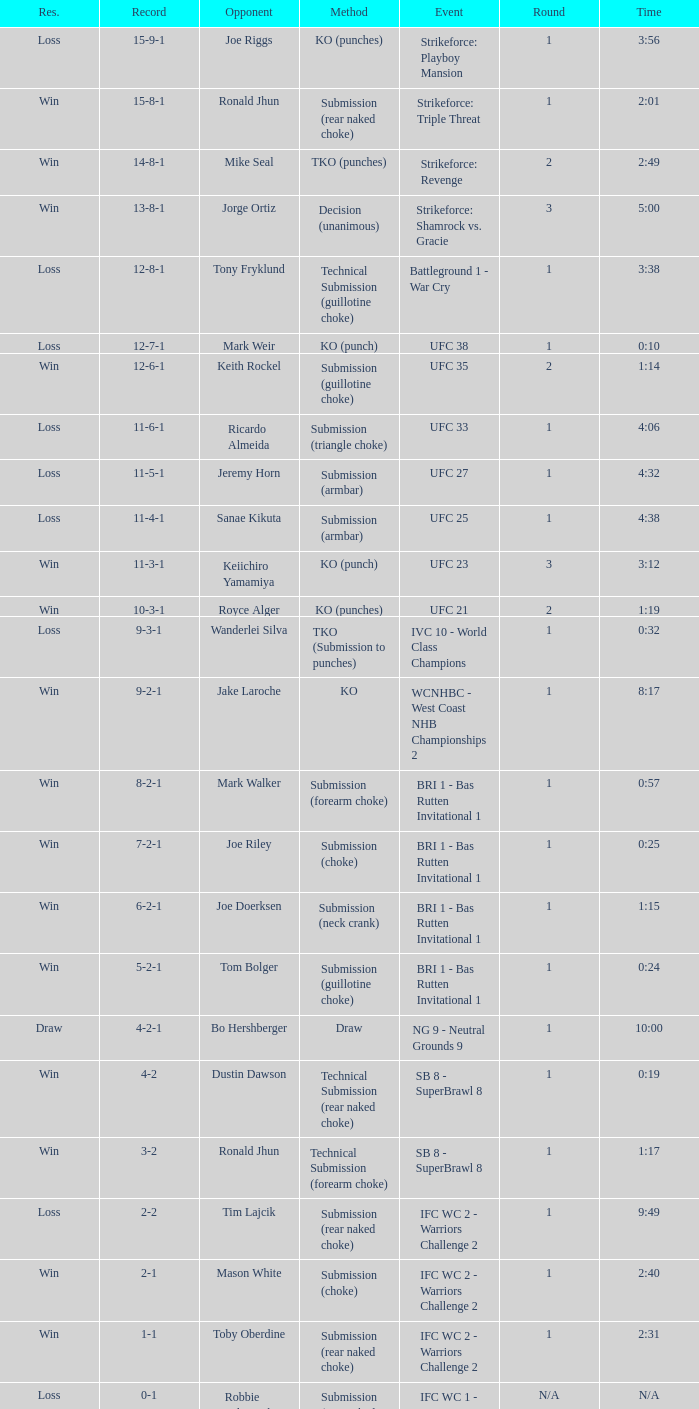What was the result when a knockout was used as the method of resolution? 9-2-1. 